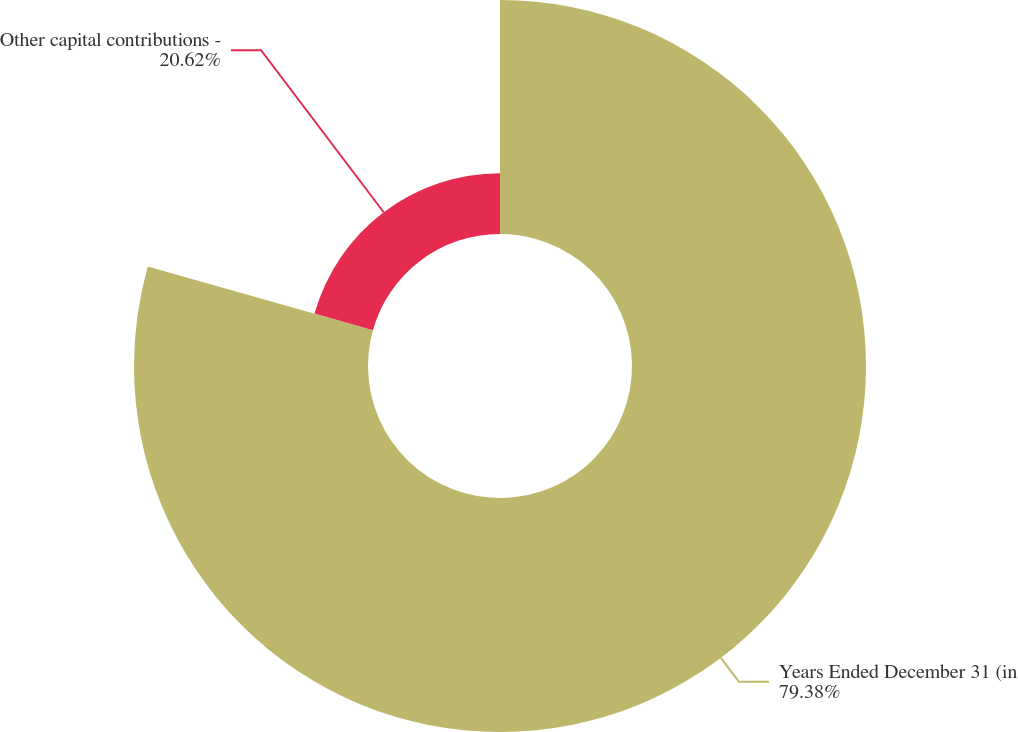Convert chart to OTSL. <chart><loc_0><loc_0><loc_500><loc_500><pie_chart><fcel>Years Ended December 31 (in<fcel>Other capital contributions -<nl><fcel>79.38%<fcel>20.62%<nl></chart> 